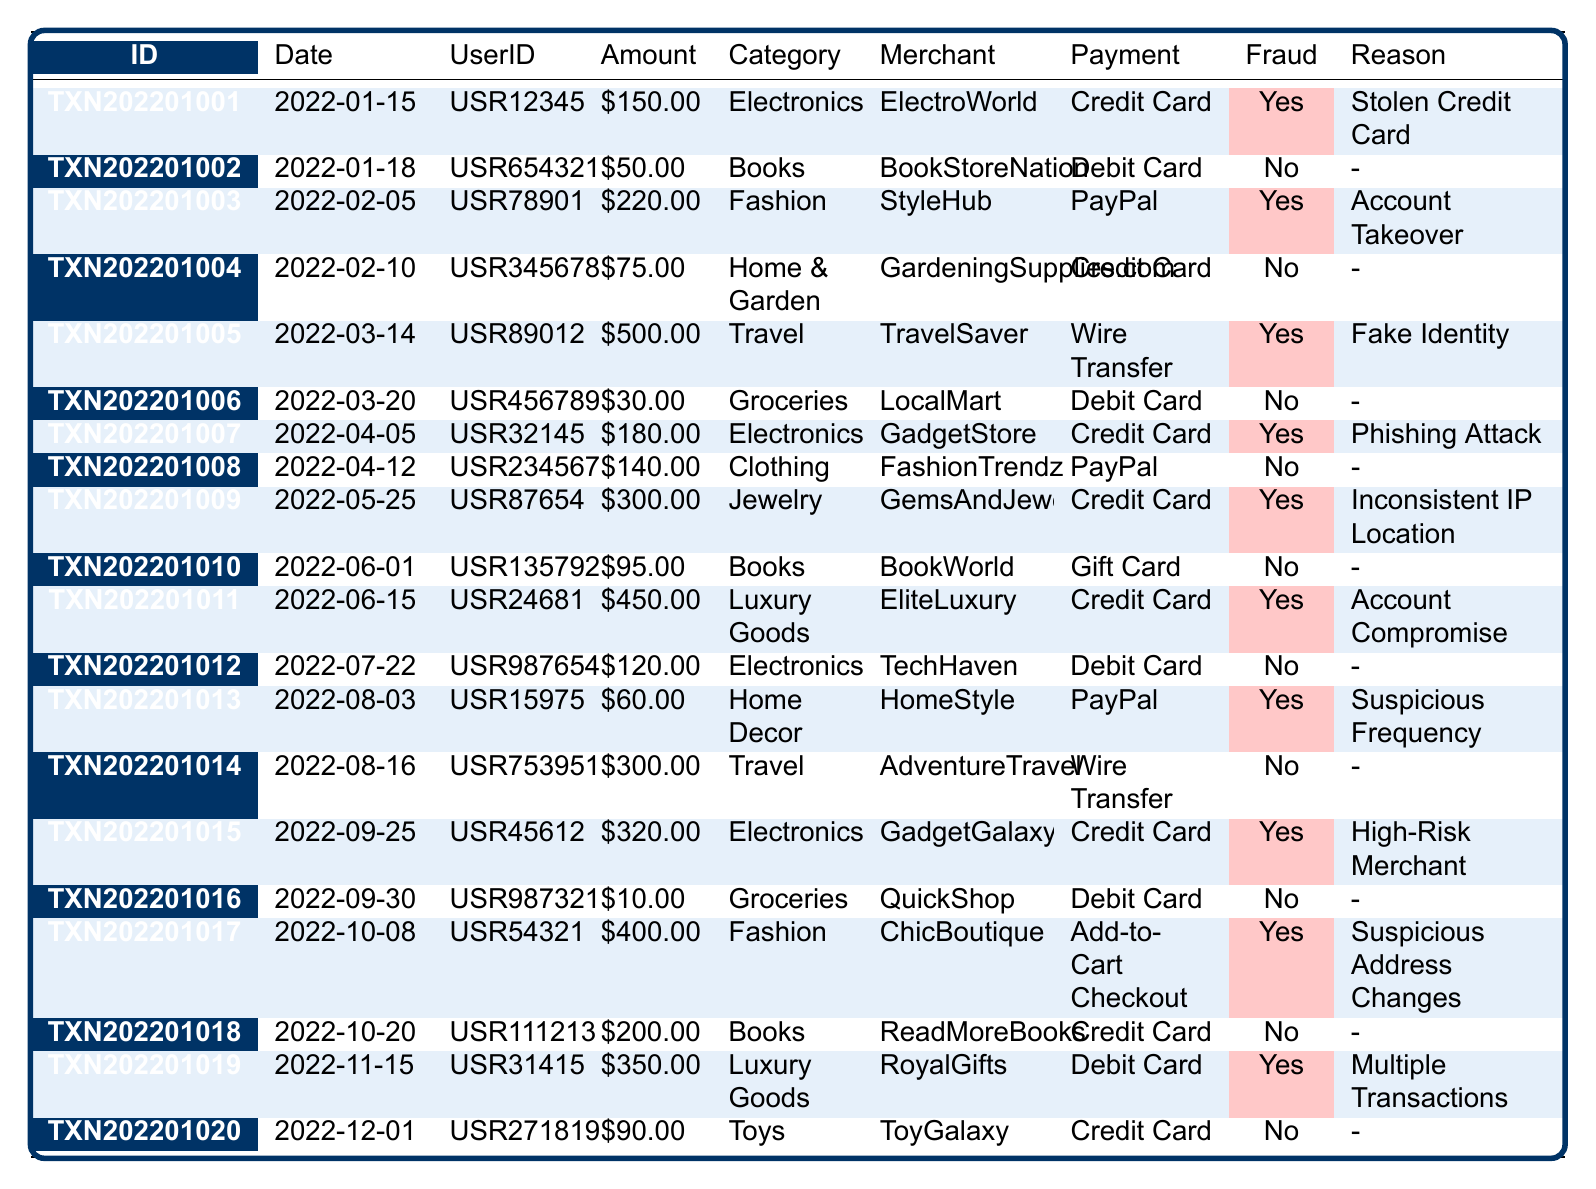What is the total amount of fraudulent transactions recorded? The fraudulent transactions are associated with the amounts of $150.00, $220.00, $500.00, $180.00, $300.00, $450.00, $60.00, $320.00, $400.00, and $350.00. Summing these amounts gives $150 + $220 + $500 + $180 + $300 + $450 + $60 + $320 + $400 + $350 = $3130.00.
Answer: $3130.00 How many transactions were made using a credit card? From the table, we can count the transactions with the payment method as "Credit Card." There are 7 such transactions.
Answer: 7 What was the reason for the largest fraudulent transaction? The largest fraudulent amount is $500.00 from the transaction with ID TXN202201005. The reason stated in the table is "Fake Identity."
Answer: Fake Identity Did any transaction occur with a gift card? There is one transaction (TXN202201010) that occurred with a gift card, and it is not fraudulent.
Answer: Yes Which category had the most fraudulent transactions? By counting the number of fraudulent incidents in each category: Electronics (3), Fashion (2), Travel (2), Home Decor (1), Luxury Goods (2), and Jewelry (1). Electronics has the most with 3 occurrences.
Answer: Electronics What percentage of the total transactions were fraudulent? There are 20 transactions in total, out of which 10 are fraudulent. The percentage is calculated as (10/20) * 100 = 50%.
Answer: 50% Which merchant had the highest fraudulent transaction amount? The highest fraudulent transaction amount is $500.00 from "TravelSaver."
Answer: TravelSaver Is there any instance of fraudulent activity where the payment method is a debit card? Yes, the entry for TXN202201006 has the payment method as Debit Card and is marked as not fraudulent.
Answer: No How many unique users were involved in fraudulent transactions? Examining the UserIDs for fraudulent transactions shows USR123456, USR789012, USR890123, USR321456, USR876543, USR246813, USR159753, USR456123, USR543216, and USR314151, totaling 10 unique users.
Answer: 10 What were the reasons for the fraudulent transactions in the Fashion category? In the Fashion category, there are two fraudulent transactions (TXN202201003 has the reason "Account Takeover" and TXN202201017 has "Suspicious Address Changes").
Answer: Account Takeover, Suspicious Address Changes What is the average amount of all the fraudulent transactions? The total amount of fraudulent transactions is $3130.00, and there are 10 fraudulent transactions. Therefore, the average is $3130.00 / 10 = $313.00.
Answer: $313.00 